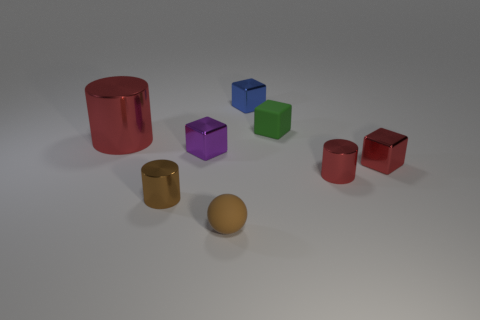Subtract all cyan balls. How many red cylinders are left? 2 Subtract all red blocks. How many blocks are left? 3 Subtract all rubber blocks. How many blocks are left? 3 Subtract 1 cylinders. How many cylinders are left? 2 Add 1 big gray metallic blocks. How many objects exist? 9 Subtract all yellow cubes. Subtract all brown cylinders. How many cubes are left? 4 Subtract all balls. How many objects are left? 7 Subtract 0 green balls. How many objects are left? 8 Subtract all brown objects. Subtract all big metal things. How many objects are left? 5 Add 2 shiny cubes. How many shiny cubes are left? 5 